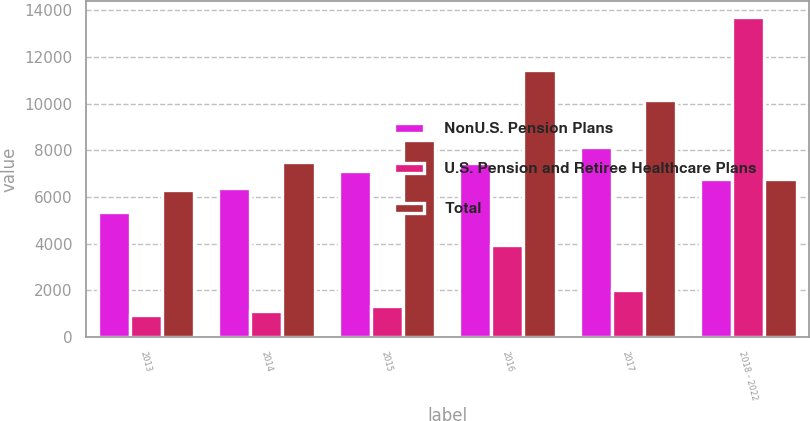Convert chart to OTSL. <chart><loc_0><loc_0><loc_500><loc_500><stacked_bar_chart><ecel><fcel>2013<fcel>2014<fcel>2015<fcel>2016<fcel>2017<fcel>2018 - 2022<nl><fcel>NonU.S. Pension Plans<fcel>5368<fcel>6399<fcel>7129<fcel>7483<fcel>8138<fcel>6764<nl><fcel>U.S. Pension and Retiree Healthcare Plans<fcel>939<fcel>1104<fcel>1321<fcel>3950<fcel>2010<fcel>13705<nl><fcel>Total<fcel>6307<fcel>7503<fcel>8450<fcel>11433<fcel>10148<fcel>6764<nl></chart> 